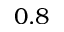<formula> <loc_0><loc_0><loc_500><loc_500>0 . 8</formula> 